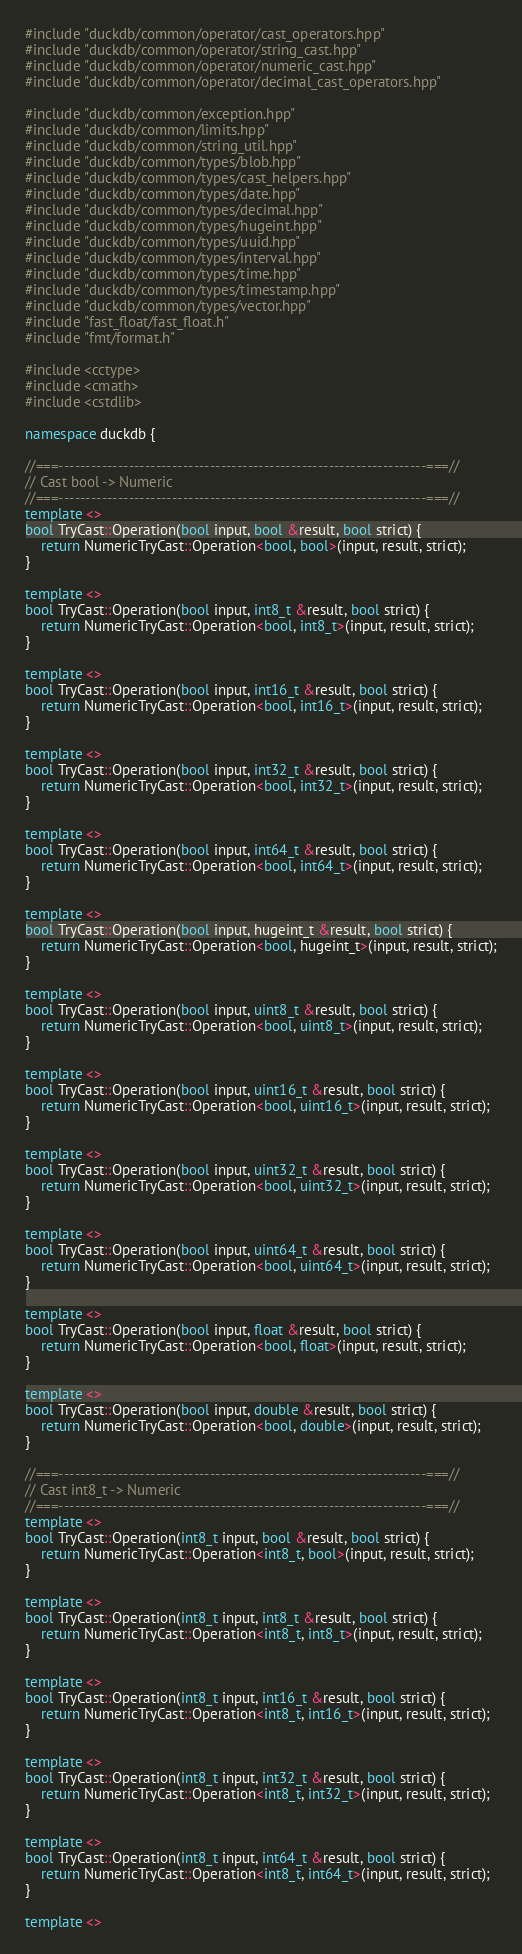Convert code to text. <code><loc_0><loc_0><loc_500><loc_500><_C++_>#include "duckdb/common/operator/cast_operators.hpp"
#include "duckdb/common/operator/string_cast.hpp"
#include "duckdb/common/operator/numeric_cast.hpp"
#include "duckdb/common/operator/decimal_cast_operators.hpp"

#include "duckdb/common/exception.hpp"
#include "duckdb/common/limits.hpp"
#include "duckdb/common/string_util.hpp"
#include "duckdb/common/types/blob.hpp"
#include "duckdb/common/types/cast_helpers.hpp"
#include "duckdb/common/types/date.hpp"
#include "duckdb/common/types/decimal.hpp"
#include "duckdb/common/types/hugeint.hpp"
#include "duckdb/common/types/uuid.hpp"
#include "duckdb/common/types/interval.hpp"
#include "duckdb/common/types/time.hpp"
#include "duckdb/common/types/timestamp.hpp"
#include "duckdb/common/types/vector.hpp"
#include "fast_float/fast_float.h"
#include "fmt/format.h"

#include <cctype>
#include <cmath>
#include <cstdlib>

namespace duckdb {

//===--------------------------------------------------------------------===//
// Cast bool -> Numeric
//===--------------------------------------------------------------------===//
template <>
bool TryCast::Operation(bool input, bool &result, bool strict) {
	return NumericTryCast::Operation<bool, bool>(input, result, strict);
}

template <>
bool TryCast::Operation(bool input, int8_t &result, bool strict) {
	return NumericTryCast::Operation<bool, int8_t>(input, result, strict);
}

template <>
bool TryCast::Operation(bool input, int16_t &result, bool strict) {
	return NumericTryCast::Operation<bool, int16_t>(input, result, strict);
}

template <>
bool TryCast::Operation(bool input, int32_t &result, bool strict) {
	return NumericTryCast::Operation<bool, int32_t>(input, result, strict);
}

template <>
bool TryCast::Operation(bool input, int64_t &result, bool strict) {
	return NumericTryCast::Operation<bool, int64_t>(input, result, strict);
}

template <>
bool TryCast::Operation(bool input, hugeint_t &result, bool strict) {
	return NumericTryCast::Operation<bool, hugeint_t>(input, result, strict);
}

template <>
bool TryCast::Operation(bool input, uint8_t &result, bool strict) {
	return NumericTryCast::Operation<bool, uint8_t>(input, result, strict);
}

template <>
bool TryCast::Operation(bool input, uint16_t &result, bool strict) {
	return NumericTryCast::Operation<bool, uint16_t>(input, result, strict);
}

template <>
bool TryCast::Operation(bool input, uint32_t &result, bool strict) {
	return NumericTryCast::Operation<bool, uint32_t>(input, result, strict);
}

template <>
bool TryCast::Operation(bool input, uint64_t &result, bool strict) {
	return NumericTryCast::Operation<bool, uint64_t>(input, result, strict);
}

template <>
bool TryCast::Operation(bool input, float &result, bool strict) {
	return NumericTryCast::Operation<bool, float>(input, result, strict);
}

template <>
bool TryCast::Operation(bool input, double &result, bool strict) {
	return NumericTryCast::Operation<bool, double>(input, result, strict);
}

//===--------------------------------------------------------------------===//
// Cast int8_t -> Numeric
//===--------------------------------------------------------------------===//
template <>
bool TryCast::Operation(int8_t input, bool &result, bool strict) {
	return NumericTryCast::Operation<int8_t, bool>(input, result, strict);
}

template <>
bool TryCast::Operation(int8_t input, int8_t &result, bool strict) {
	return NumericTryCast::Operation<int8_t, int8_t>(input, result, strict);
}

template <>
bool TryCast::Operation(int8_t input, int16_t &result, bool strict) {
	return NumericTryCast::Operation<int8_t, int16_t>(input, result, strict);
}

template <>
bool TryCast::Operation(int8_t input, int32_t &result, bool strict) {
	return NumericTryCast::Operation<int8_t, int32_t>(input, result, strict);
}

template <>
bool TryCast::Operation(int8_t input, int64_t &result, bool strict) {
	return NumericTryCast::Operation<int8_t, int64_t>(input, result, strict);
}

template <></code> 